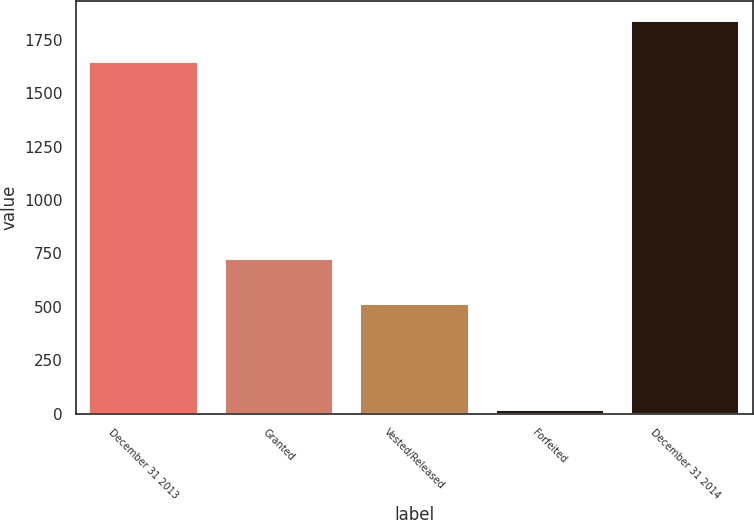Convert chart. <chart><loc_0><loc_0><loc_500><loc_500><bar_chart><fcel>December 31 2013<fcel>Granted<fcel>Vested/Released<fcel>Forfeited<fcel>December 31 2014<nl><fcel>1647<fcel>723<fcel>513<fcel>20<fcel>1837<nl></chart> 